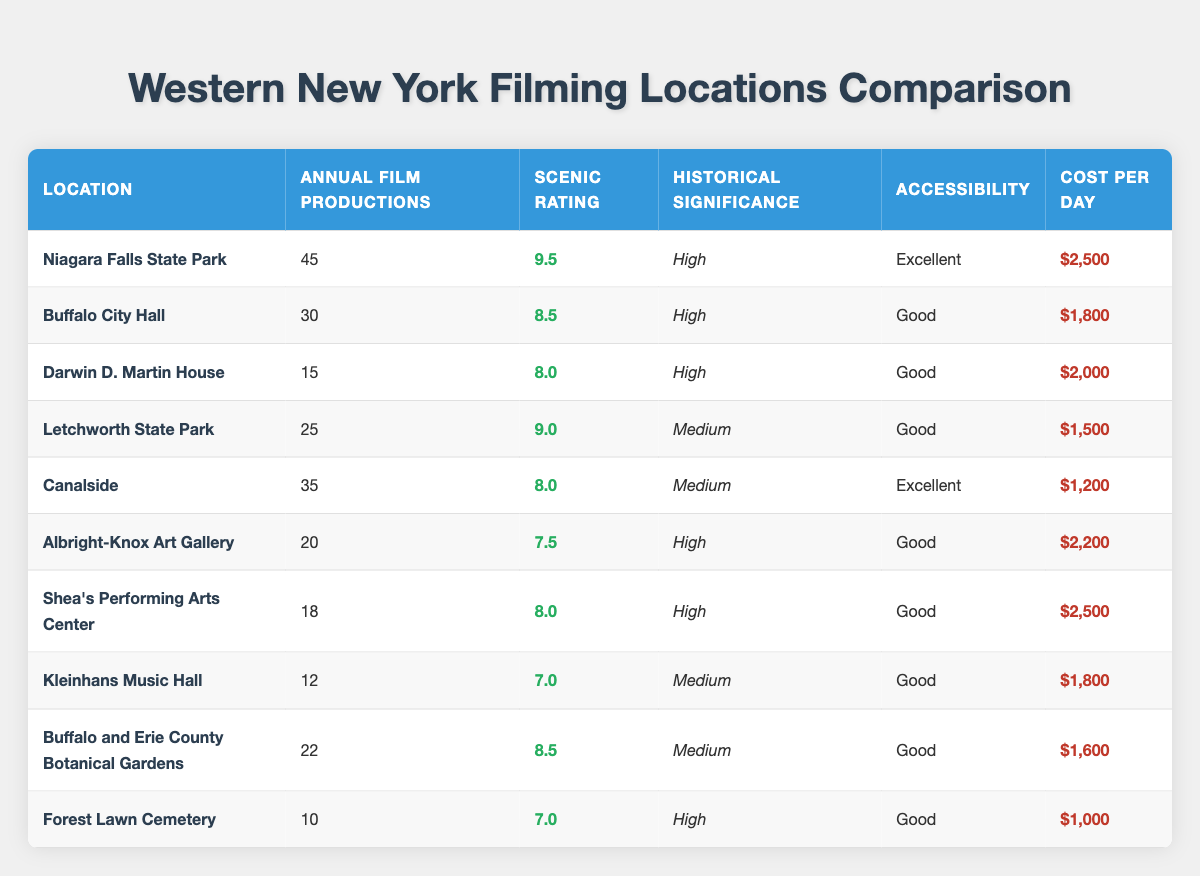What filming location has the highest annual film productions? The location with the highest annual film productions is Niagara Falls State Park, which has 45 annual productions. This can be found in the "Annual Film Productions" column of the table.
Answer: Niagara Falls State Park Which filming location has the lowest cost per day? The filming location with the lowest cost per day is Forest Lawn Cemetery, which costs $1,000. This can be found in the "Cost Per Day" column, where we can see that it is the smallest value.
Answer: Forest Lawn Cemetery What is the average scenic rating of all the locations? To find the average scenic rating, we add the scenic ratings of all locations: (9.5 + 8.5 + 8.0 + 9.0 + 8.0 + 7.5 + 8.0 + 7.0 + 8.5 + 7.0) = 81.5. Then, we divide by the number of locations, which is 10. So, the average scenic rating is 81.5 / 10 = 8.15.
Answer: 8.15 Is Albright-Knox Art Gallery more accessible than Shea's Performing Arts Center? Both locations are labeled as "Good" for accessibility. Since they have the same rating, the statement is false – they are equally accessible. This comparison is straightforward by looking at the "Accessibility" column.
Answer: No How many locations have a historical significance rated as "High"? Upon reviewing the table, the locations with a "High" historical significance are Niagara Falls State Park, Buffalo City Hall, Darwin D. Martin House, Albright-Knox Art Gallery, and Shea's Performing Arts Center. This indicates that there are 5 locations with high historical significance.
Answer: 5 What is the total number of annual film productions for locations with "Medium" historical significance? The locations with "Medium" historical significance are Letchworth State Park, Canalside, Buffalo and Erie County Botanical Gardens, and Kleinhans Music Hall. Their annual productions are 25, 35, 22, and 12, respectively. Adding these productions gives 25 + 35 + 22 + 12 = 94. Thus, the total number of annual productions for these locations is 94.
Answer: 94 Which location is more scenic, Buffalo City Hall or Letchworth State Park? Buffalo City Hall has a scenic rating of 8.5, while Letchworth State Park has a scenic rating of 9.0. Therefore, when comparing both ratings, Letchworth State Park is more scenic. This is determined by looking at the "Scenic Rating" column for both locations.
Answer: Letchworth State Park What is the total cost per day for the top three locations based on annual film productions? The top three locations by annual productions are Niagara Falls State Park ($2,500), Canalside ($1,200), and Buffalo City Hall ($1,800). To find the total, we add these costs: 2500 + 1200 + 1800 = 4500. Therefore, the total cost per day for the top three locations is $4,500.
Answer: $4,500 